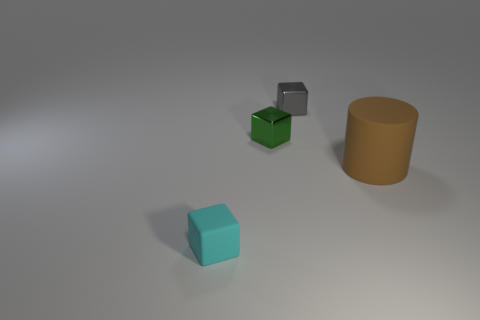Is the size of the green thing the same as the brown object?
Offer a terse response. No. What is the size of the matte object that is the same shape as the gray metallic object?
Give a very brief answer. Small. What number of objects are both to the right of the green cube and left of the big brown rubber object?
Ensure brevity in your answer.  1. Are the brown thing and the tiny green cube that is in front of the tiny gray cube made of the same material?
Ensure brevity in your answer.  No. What number of cyan objects are either small metallic things or big rubber objects?
Provide a short and direct response. 0. Is there another matte thing that has the same size as the brown thing?
Make the answer very short. No. What material is the object that is right of the metallic cube behind the small shiny object on the left side of the tiny gray shiny object?
Offer a terse response. Rubber. Is the number of cyan things that are behind the tiny gray metallic object the same as the number of tiny green balls?
Provide a short and direct response. Yes. Is the tiny object that is in front of the brown rubber cylinder made of the same material as the object that is on the right side of the small gray block?
Your answer should be compact. Yes. How many things are tiny brown matte cylinders or rubber things in front of the brown object?
Give a very brief answer. 1. 